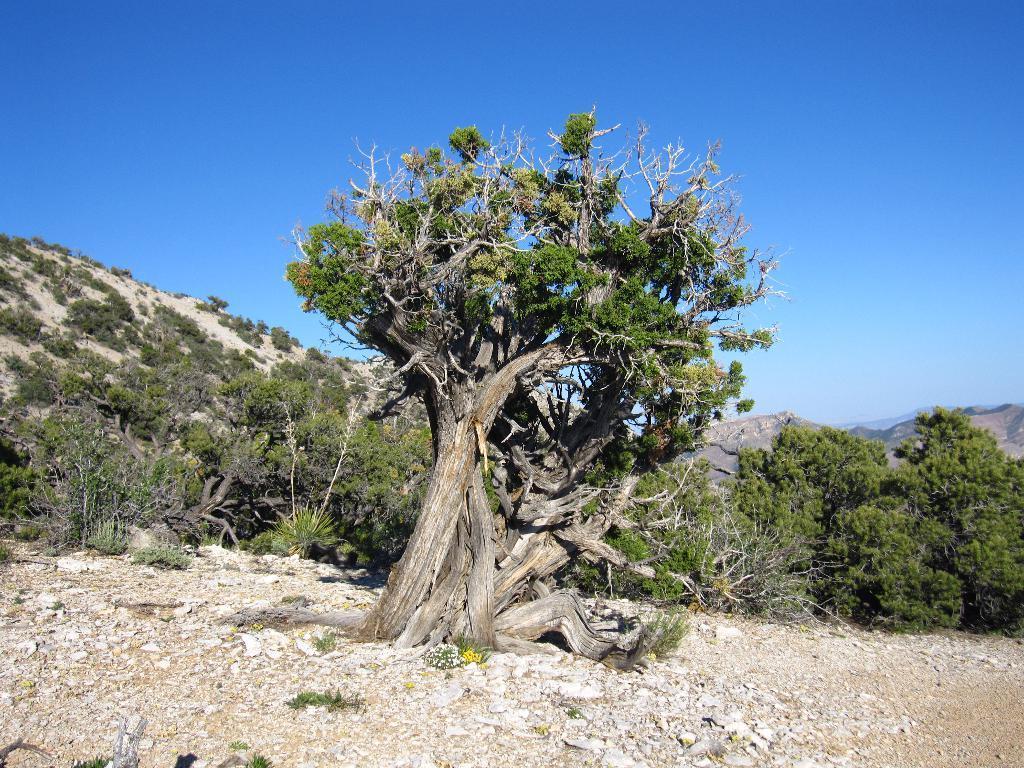Could you give a brief overview of what you see in this image? In this image we can see a few trees on the ground and in the background there are a few mountains and the sky. 